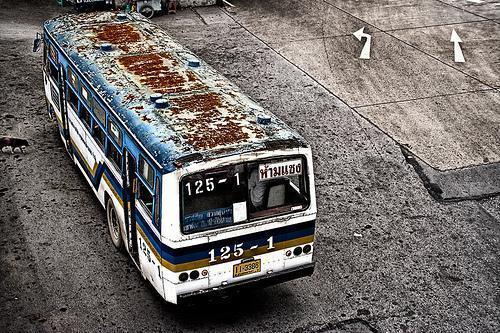What work does this bus need to have done on it?
Pick the right solution, then justify: 'Answer: answer
Rationale: rationale.'
Options: Wheels rotated, paint roof, reverse signaling, retraining. Answer: paint roof.
Rationale: Based on the color scheme of the rest of the bus the roof does not appear to be its original color and appears to be disrepair. if a painted surface looks this way it is in need of new paint. 